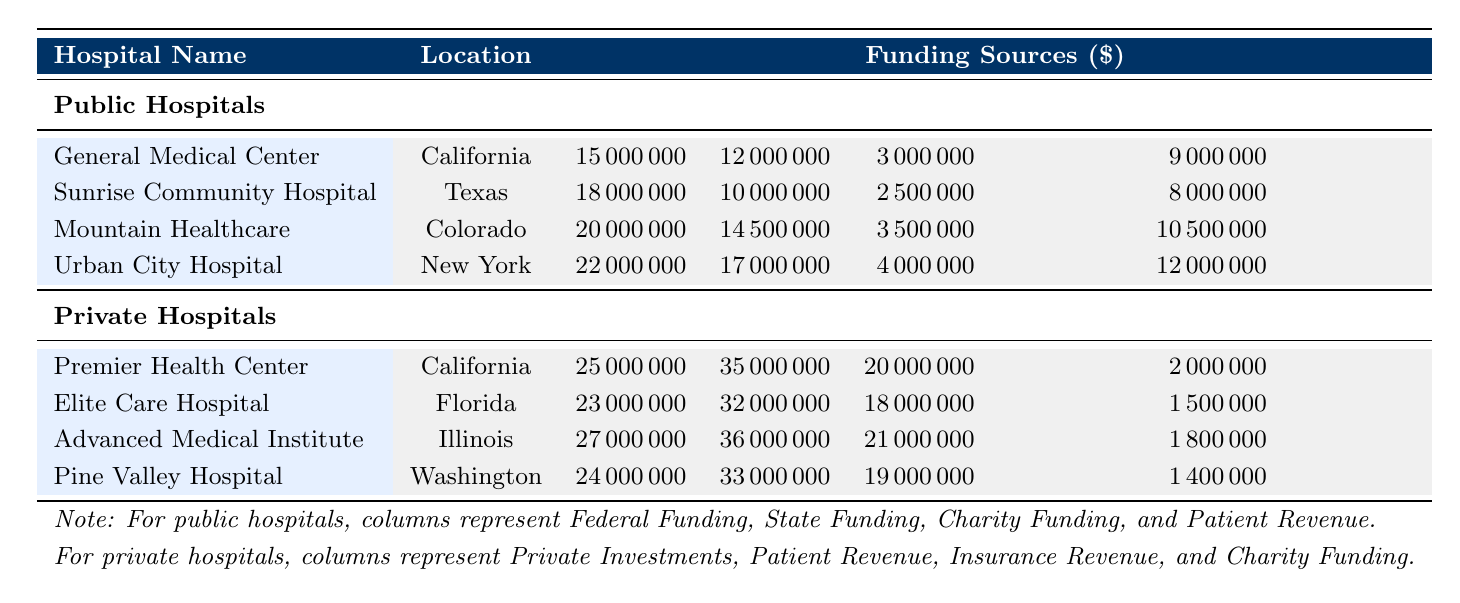What is the total Federal Funding allocated to Public Hospitals? To find the total Federal Funding for Public Hospitals, sum the respective Federal Funding for each hospital: 15,000,000 + 18,000,000 + 20,000,000 + 22,000,000 = 75,000,000.
Answer: 75,000,000 Which hospital received the highest State Funding? The State Funding amounts for Public Hospitals are: 12,000,000, 10,000,000, 14,500,000, and 17,000,000. The maximum among these is 17,000,000 for Urban City Hospital.
Answer: Urban City Hospital Does any private hospital have more Charity Funding than the highest Charity Funding for a public hospital? The highest Charity Funding for Public Hospitals is 4,000,000. The Charity Fundings for Private Hospitals are 2,000,000, 1,500,000, 1,800,000, and 1,400,000. None exceeds 4,000,000.
Answer: No What is the average Patient Revenue for Public Hospitals? For Public Hospitals, the Patient Revenues are 9,000,000, 8,000,000, 10,500,000, and 12,000,000. To find the average, sum them: 9,000,000 + 8,000,000 + 10,500,000 + 12,000,000 = 39,500,000. Then divide by 4 (the number of hospitals): 39,500,000 / 4 = 9,875,000.
Answer: 9,875,000 Which type of hospital generated more total Patient Revenue in FY 2022? Total Patient Revenue for Public Hospitals sums to 39,500,000 (9,000,000 + 8,000,000 + 10,500,000 + 12,000,000) and for Private Hospitals it sums to 1,380,000,000 (35,000,000 + 32,000,000 + 36,000,000 + 33,000,000). Private Hospitals generated more revenue.
Answer: Private Hospitals What is the difference in total Federal Funding and Private Investments? Total Federal Funding is 75,000,000 and total Private Investments is 102,000,000 (25,000,000 + 23,000,000 + 27,000,000 + 24,000,000). The difference is 102,000,000 - 75,000,000 = 27,000,000.
Answer: 27,000,000 Is the Insurance Revenue for Advanced Medical Institute higher than the combined Charity Funding of all Public Hospitals? Total Charity Funding for Public Hospitals is 3,000,000 + 2,500,000 + 3,500,000 + 4,000,000 = 13,000,000. The Insurance Revenue for Advanced Medical Institute is 21,000,000 which is higher than 13,000,000.
Answer: Yes Which Public Hospital has the highest total funding when combining all sources? For Public Hospitals, total funding sums are as follows: General Medical Center (15,000,000 + 12,000,000 + 3,000,000 + 9,000,000 = 39,000,000), Sunrise Community Hospital (18,000,000 + 10,000,000 + 2,500,000 + 8,000,000 = 38,500,000), Mountain Healthcare (20,000,000 + 14,500,000 + 3,500,000 + 10,500,000 = 48,500,000), and Urban City Hospital (22,000,000 + 17,000,000 + 4,000,000 + 12,000,000 = 55,000,000). Urban City Hospital has the highest total funding.
Answer: Urban City Hospital 